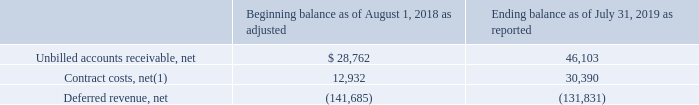Customer Contract - Related Balance Sheet Amounts
The Company generally invoices customers in annual installments payable in advance. The difference between the timing of revenue recognition and the timing of billings results in the recognition of unbilled accounts receivable or deferred revenue in the consolidated balance sheets. Amounts related to customer contract-related arrangements are included on the consolidated balance sheets as of August 1, 2018 and July 31, 2019 as follows (in thousands):
(1) The short- and long-term portions of this balance are reported in ‘Prepaid expenses and other current assets’ and ‘Other assets,’ respectively, on the consolidated balance sheets.
Unbilled accounts receivable
Unbilled accounts receivable includes those amounts that are unbilled due to agreed-upon contractual terms in which billing occurs subsequent to revenue recognition. This situation typically occurs when the Company transfers control of time-based software licenses to customers up-front, but invoices customers annually over the term of the license, which is typically two years.
During the fiscal year ended July 31, 2019, the Company transferred control of a ten year timebased license that resulted in $9.7 million of unbilled accounts receivable as of July 31, 2019, representing future billings in years two through ten of the license term.
Unbilled accounts receivable is classified as either current or non-current based on the duration of remaining time between the date of the consolidated balance sheets and the anticipated due date of the underlying receivables.
Contract costs
Contract costs consist of customer acquisition costs and costs to fulfill a contract, which includes commissions and their related payroll taxes, royalties, and referral fees. Contract costs are classified as either current or non-current based on the duration of time remaining between the date of the consolidated balance sheets and the anticipated amortization date of the associated costs.
The current portion of contract costs as of July 31, 2019 in the amount of $7.0 million is included in prepaid and other current assets on the Company’s consolidated balance sheets. The non-current portion of contract costs as of July 31, 2019 in the amount of $23.4 million is included in other assets on the Company’s consolidated balance sheets. The Company amortized $5.5 million of contract costs during the fiscal year ended July 31, 2019.
Deferred revenue
Deferred revenue consists of amounts that have been invoiced and for which the Company has the right to bill, but that have not been recognized as revenue because the related goods or services have not been transferred. Deferred revenue that will be realized during the 12-month period following the date of the consolidated balance sheets is recorded as current, and the remaining deferred revenue is recorded as non-current.
During the fiscal year ended July 31, 2019, the Company recognized revenue of $112.2 million related to the Company’s deferred revenue balance as of August 1, 2018.
What does the unbilled accounts receivables include? Includes those amounts that are unbilled due to agreed-upon contractual terms in which billing occurs subsequent to revenue recognition. What was the amount of unbilled accounts receivables in 2019 post transfer of control? $9.7 million. What was the Contract costs, net in 2018 and 2019 respectively?
Answer scale should be: thousand. 12,932, 30,390. What was the change in the Unbilled accounts receivable, net from 2018 to 2019?
Answer scale should be: thousand. 28,762 - 46,103
Answer: -17341. What was the average Contract costs, net for 2018 and 2019?
Answer scale should be: thousand. (12,932 + 30,390) / 2
Answer: 21661. In which year was Contract costs, net less than 20,000 thousands? Locate and analyze contract costs, net(1) in row 3
answer: 2018. 